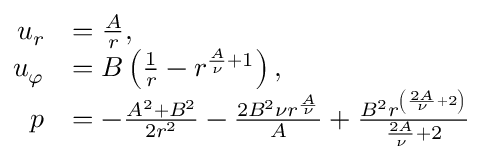<formula> <loc_0><loc_0><loc_500><loc_500>{ \begin{array} { r l } { u _ { r } } & { = { \frac { A } { r } } , } \\ { u _ { \varphi } } & { = B \left ( { \frac { 1 } { r } } - r ^ { { \frac { A } { \nu } } + 1 } \right ) , } \\ { p } & { = - { \frac { A ^ { 2 } + B ^ { 2 } } { 2 r ^ { 2 } } } - { \frac { 2 B ^ { 2 } \nu r ^ { \frac { A } { \nu } } } { A } } + { \frac { B ^ { 2 } r ^ { \left ( { \frac { 2 A } { \nu } } + 2 \right ) } } { { \frac { 2 A } { \nu } } + 2 } } } \end{array} }</formula> 